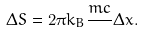<formula> <loc_0><loc_0><loc_500><loc_500>\Delta S = 2 \pi k _ { B } \frac { m c } { } \Delta x .</formula> 